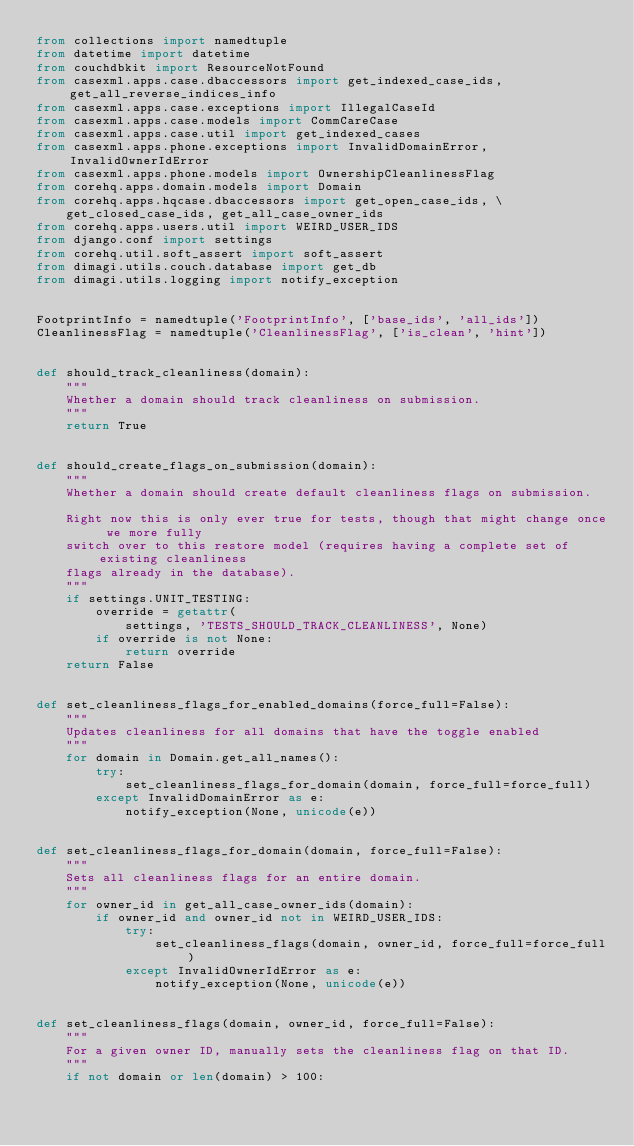Convert code to text. <code><loc_0><loc_0><loc_500><loc_500><_Python_>from collections import namedtuple
from datetime import datetime
from couchdbkit import ResourceNotFound
from casexml.apps.case.dbaccessors import get_indexed_case_ids, get_all_reverse_indices_info
from casexml.apps.case.exceptions import IllegalCaseId
from casexml.apps.case.models import CommCareCase
from casexml.apps.case.util import get_indexed_cases
from casexml.apps.phone.exceptions import InvalidDomainError, InvalidOwnerIdError
from casexml.apps.phone.models import OwnershipCleanlinessFlag
from corehq.apps.domain.models import Domain
from corehq.apps.hqcase.dbaccessors import get_open_case_ids, \
    get_closed_case_ids, get_all_case_owner_ids
from corehq.apps.users.util import WEIRD_USER_IDS
from django.conf import settings
from corehq.util.soft_assert import soft_assert
from dimagi.utils.couch.database import get_db
from dimagi.utils.logging import notify_exception


FootprintInfo = namedtuple('FootprintInfo', ['base_ids', 'all_ids'])
CleanlinessFlag = namedtuple('CleanlinessFlag', ['is_clean', 'hint'])


def should_track_cleanliness(domain):
    """
    Whether a domain should track cleanliness on submission.
    """
    return True


def should_create_flags_on_submission(domain):
    """
    Whether a domain should create default cleanliness flags on submission.

    Right now this is only ever true for tests, though that might change once we more fully
    switch over to this restore model (requires having a complete set of existing cleanliness
    flags already in the database).
    """
    if settings.UNIT_TESTING:
        override = getattr(
            settings, 'TESTS_SHOULD_TRACK_CLEANLINESS', None)
        if override is not None:
            return override
    return False


def set_cleanliness_flags_for_enabled_domains(force_full=False):
    """
    Updates cleanliness for all domains that have the toggle enabled
    """
    for domain in Domain.get_all_names():
        try:
            set_cleanliness_flags_for_domain(domain, force_full=force_full)
        except InvalidDomainError as e:
            notify_exception(None, unicode(e))


def set_cleanliness_flags_for_domain(domain, force_full=False):
    """
    Sets all cleanliness flags for an entire domain.
    """
    for owner_id in get_all_case_owner_ids(domain):
        if owner_id and owner_id not in WEIRD_USER_IDS:
            try:
                set_cleanliness_flags(domain, owner_id, force_full=force_full)
            except InvalidOwnerIdError as e:
                notify_exception(None, unicode(e))


def set_cleanliness_flags(domain, owner_id, force_full=False):
    """
    For a given owner ID, manually sets the cleanliness flag on that ID.
    """
    if not domain or len(domain) > 100:</code> 